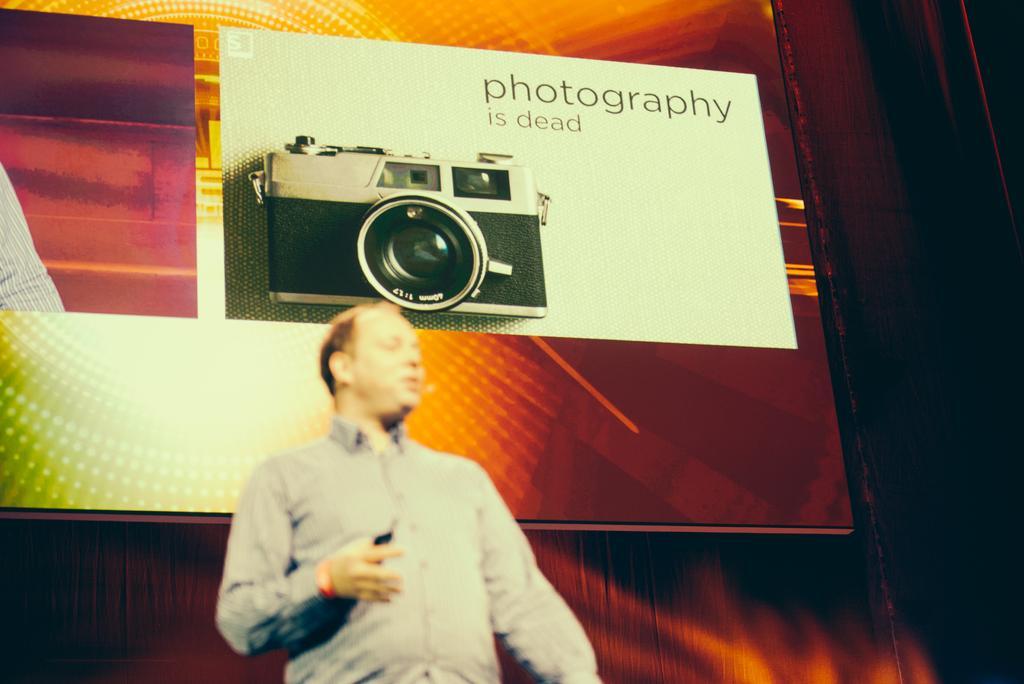Please provide a concise description of this image. In this picture we can see a man and in the background we can see a screen and on the screen we can see a camera and text. 